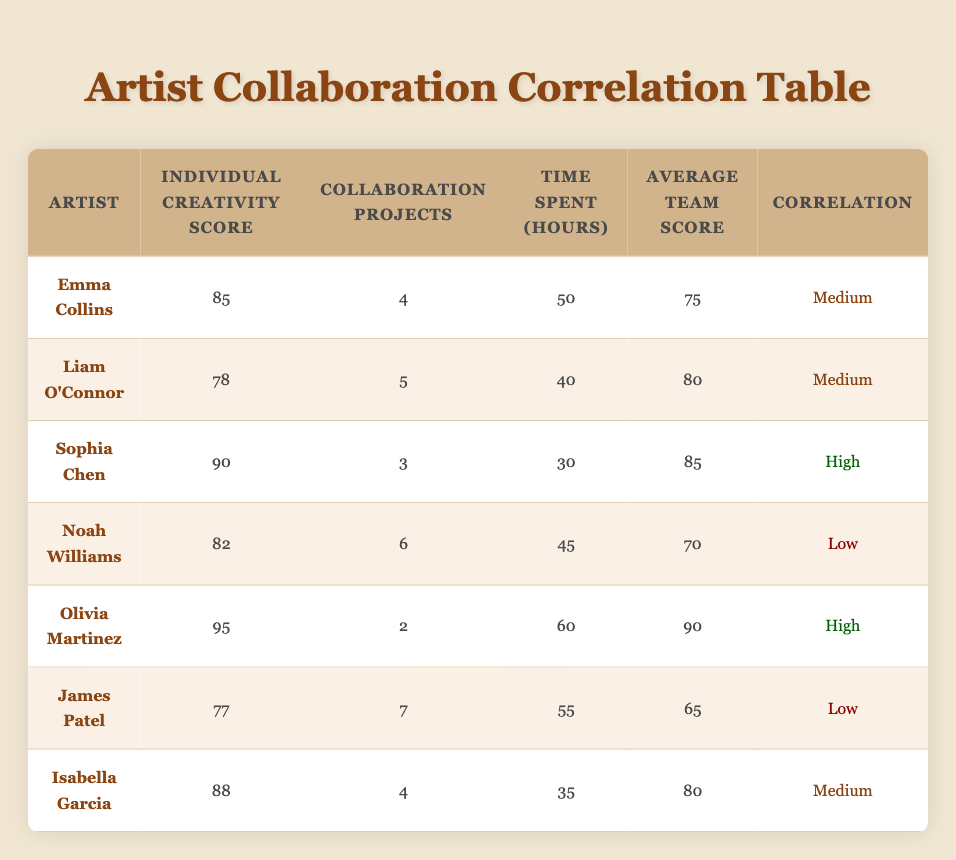What is the individual creativity score of Sophia Chen? The table lists Sophia Chen in the row under "Artist", and her "Individual Creativity Score" is shown in the same row. Looking directly at her details, the score is 90.
Answer: 90 How many collaboration projects did Liam O'Connor participate in? By locating Liam O'Connor in the table, we see that the number of "Collaboration Projects" associated with him is displayed. According to the table, Liam O'Connor participated in 5 collaborations.
Answer: 5 What is the average team score of Emma Collins? Emma Collins' "Average Team Score" is directly stated in her row. By checking the table, it is clear that her average score is 75.
Answer: 75 Is there a high correlation between individual creativity scores and the number of collaboration projects? To evaluate this, we can check the correlation values provided in the table for the relationships. Both Sophia Chen and Olivia Martinez have high creativity scores but different numbers of collaboration projects, and Noah Williams shows a low correlation despite having more collaborations. This suggests that the correlation is not consistently high.
Answer: No What is the difference in individual creativity scores between Olivia Martinez and James Patel? Olivia Martinez's individual creativity score is 95, and James Patel's is 77. The difference is calculated by subtracting Patel's score from Martinez's score: 95 - 77 = 18. Therefore, Olivia's score is 18 points higher than James's.
Answer: 18 How many total collaboration projects did all artists in the table participate in? We can find the total number of collaboration projects by adding the values in the "Collaboration Projects" column: 4 + 5 + 3 + 6 + 2 + 7 + 4 = 31. Thus, the sum of all collaboration projects equals 31.
Answer: 31 Is Olivia Martinez the artist with the highest individual creativity score? Checking through the "Individual Creativity Score" column, Olivia has a score of 95. No other artist listed has a score higher than this, confirming that Olivia Martinez has the highest score.
Answer: Yes What is the average time spent on projects by artists with a medium correlation? The artists showing medium correlation are Emma Collins, Liam O'Connor, and Isabella Garcia. Their time spent is 50, 40, and 35 hours respectively. Summing these gives 50 + 40 + 35 = 125, and averaging it over the 3 artists (125/3) yields approximately 41.67 hours.
Answer: 41.67 